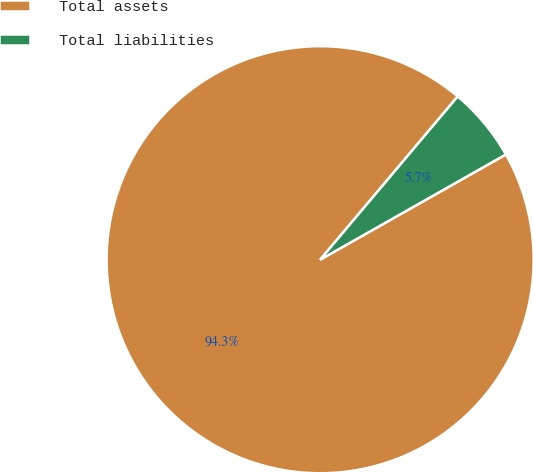Convert chart to OTSL. <chart><loc_0><loc_0><loc_500><loc_500><pie_chart><fcel>Total assets<fcel>Total liabilities<nl><fcel>94.35%<fcel>5.65%<nl></chart> 